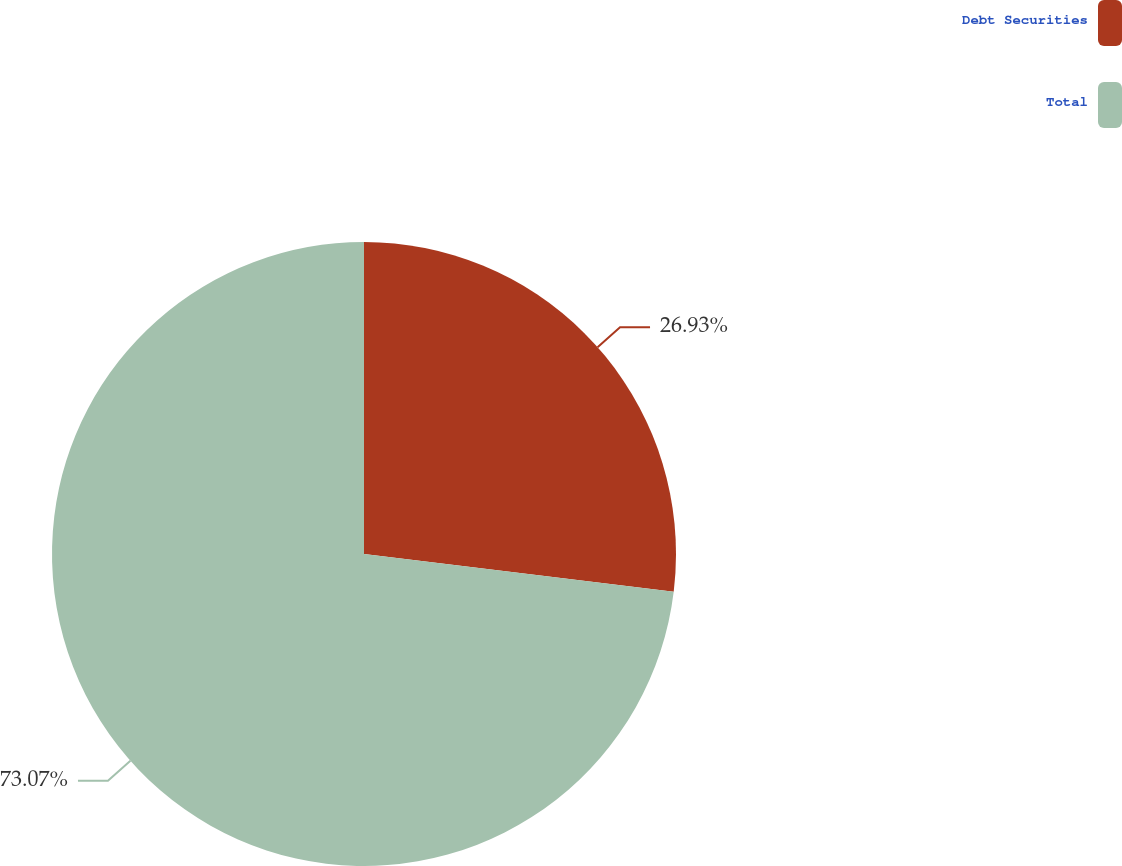Convert chart to OTSL. <chart><loc_0><loc_0><loc_500><loc_500><pie_chart><fcel>Debt Securities<fcel>Total<nl><fcel>26.93%<fcel>73.07%<nl></chart> 